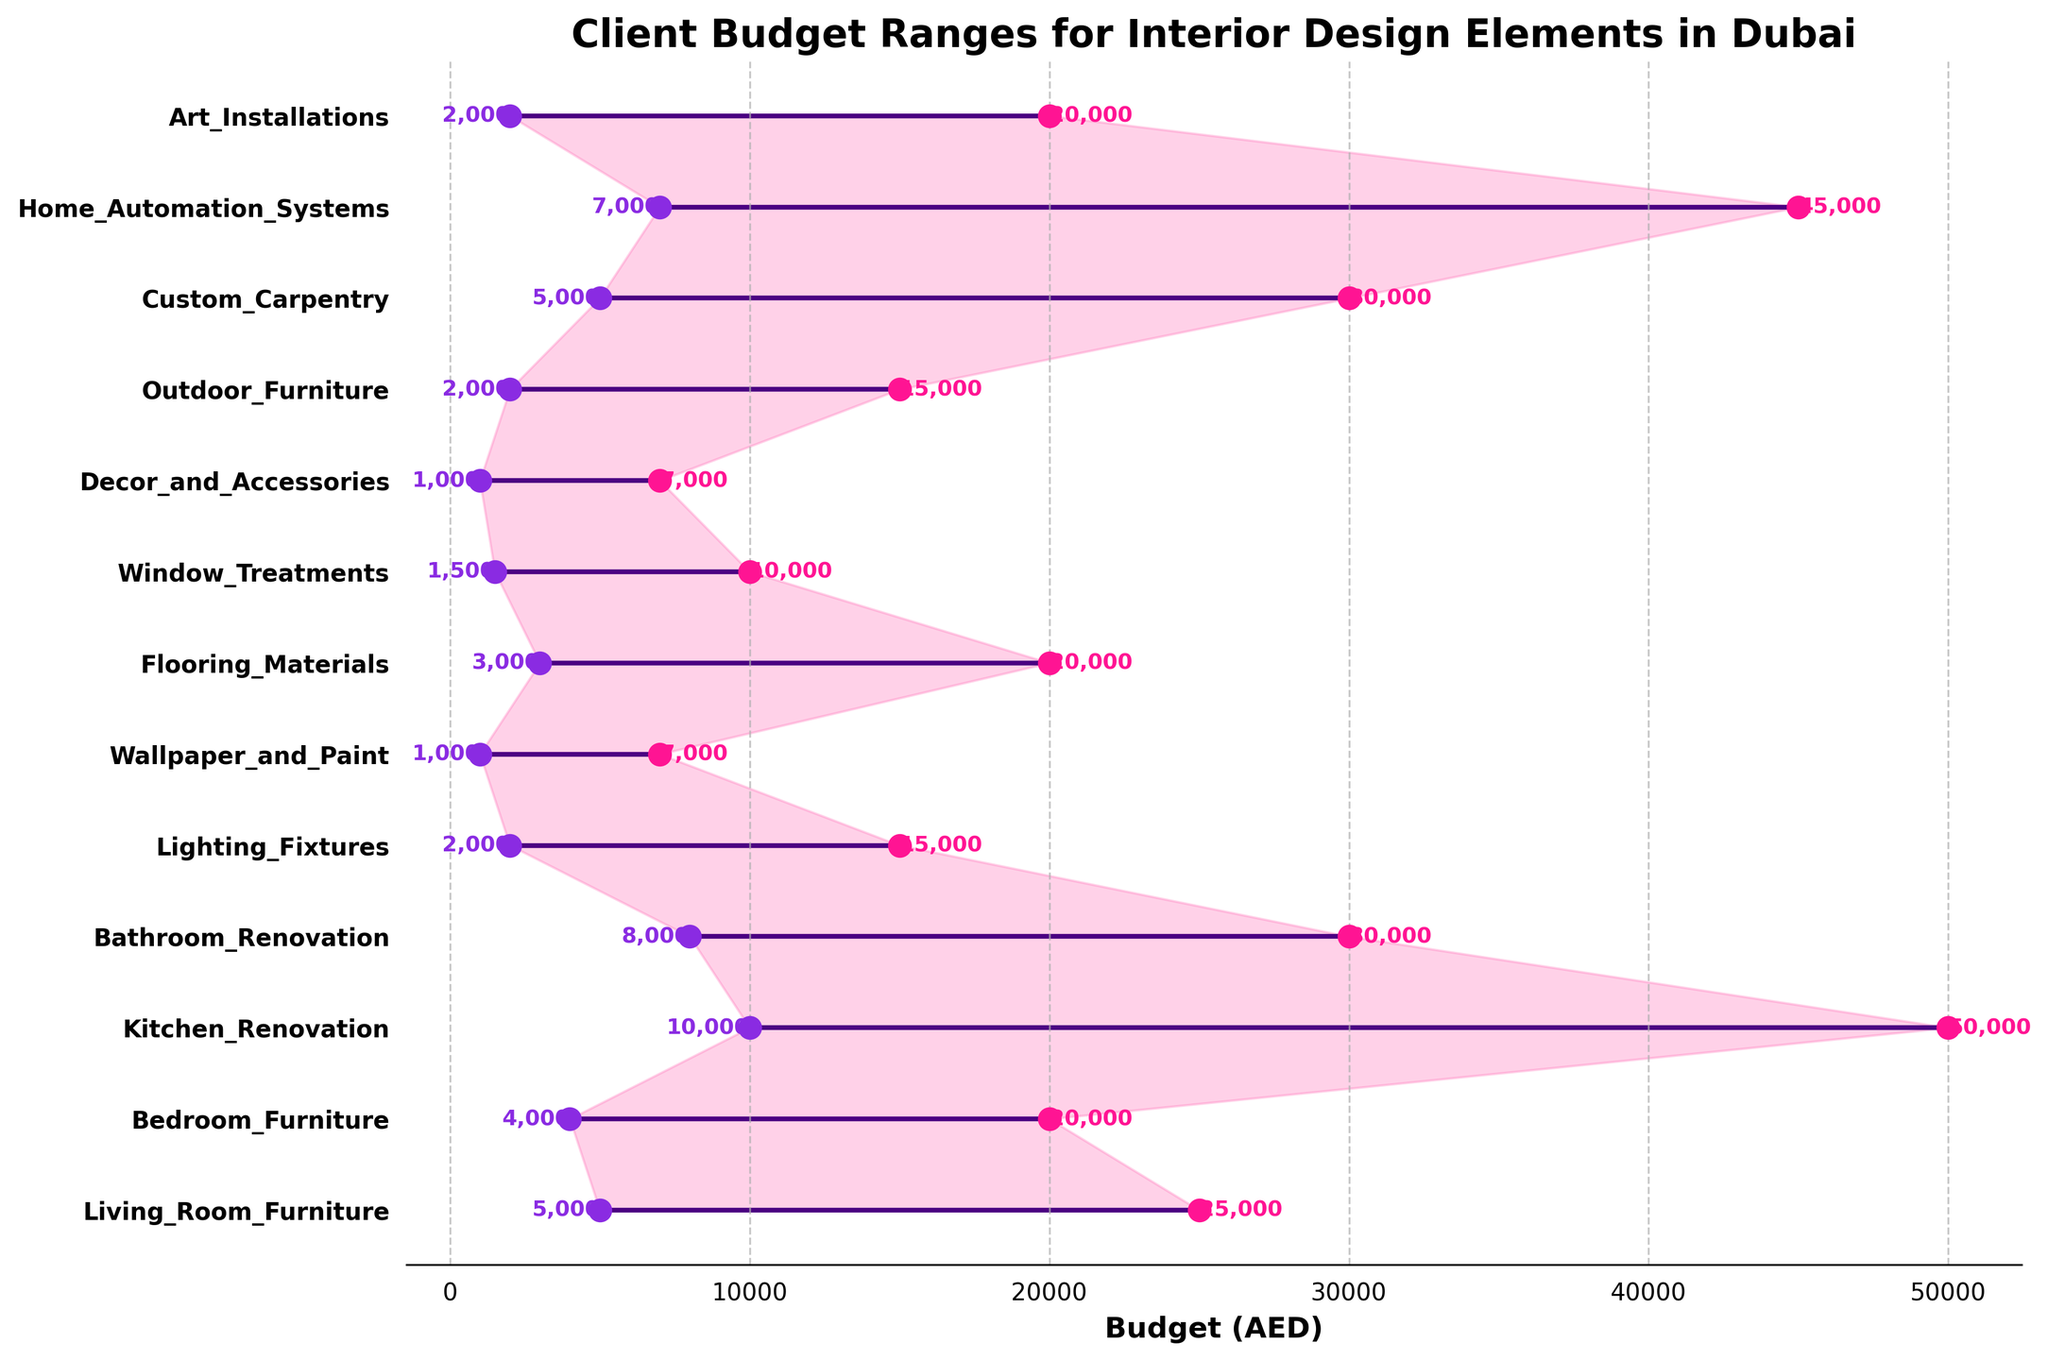Which design element has the highest maximum budget? By looking for the highest point on the x-axis and finding the corresponding y-axis label, the highest maximum budget is for 'Kitchen Renovation' with a maximum of 50,000 AED.
Answer: Kitchen Renovation What's the minimum budget range for 'Decor and Accessories'? The minimum budget for 'Decor and Accessories' can be found by looking at the left endpoint of the range which is at 1,000 AED.
Answer: 1,000 AED Which design element has the smallest difference between minimum and maximum budgets? To find this, look for the shortest horizontal line in the range area chart. 'Wallpaper and Paint' has the smallest budget range from 1,000 AED to 7,000 AED, a difference of 6,000 AED.
Answer: Wallpaper and Paint How many design elements have a maximum budget below 25,000 AED? Counting the lines where the right endpoint is below 25,000 AED yields a total of 11 elements.
Answer: 11 Which two design elements have the same maximum budget of 20,000 AED? Looking for lines that end at 20,000 AED on the x-axis, 'Bedroom Furniture' and 'Art Installations' both have the same maximum budget of 20,000 AED.
Answer: Bedroom Furniture and Art Installations Calculate the average maximum budget of 'Lighting Fixtures', 'Window Treatments', and 'Outdoor Furniture'. Average is calculated by summing the maximums and dividing by the number of elements: (15,000 + 10,000 + 15,000) / 3 = 40,000 / 3 ≈ 13,333 AED.
Answer: 13,333 AED Compare the budget range of 'Bathroom Renovation' and 'Custom Carpentry'. Which one has a wider range? 'Bathroom Renovation' ranges from 8,000 to 30,000 (22,000 AED) while 'Custom Carpentry' ranges from 5,000 to 30,000 (25,000 AED), so 'Custom Carpentry' has a wider range by 3,000 AED.
Answer: Custom Carpentry What is the median value of the maximum budgets for all design elements? Ordering all maximum budgets and finding the middle value: (7,000, 7,000, 10,000, 15,000, 15,000, 20,000, 20,000, 25,000, 30,000, 30,000, 30,000, 45,000, 50,000). Median is the 7th value, which is 20,000 AED.
Answer: 20,000 AED Which design element has the closest minimum and maximum budgets to 'Living Room Furniture'? ‘Living Room Furniture' ranges from 5,000 to 25,000 AED. Comparing other ranges, 'Bedroom Furniture' with 4,000 to 20,000 AED is closest.
Answer: Bedroom Furniture What is the total combined maximum budget of all design elements? Summing all maximum budgets: 25,000 + 20,000 + 50,000 + 30,000 + 15,000 + 7,000 + 20,000 + 10,000 + 7,000 + 15,000 + 30,000 + 45,000 + 20,000 = 294,000 AED.
Answer: 294,000 AED 